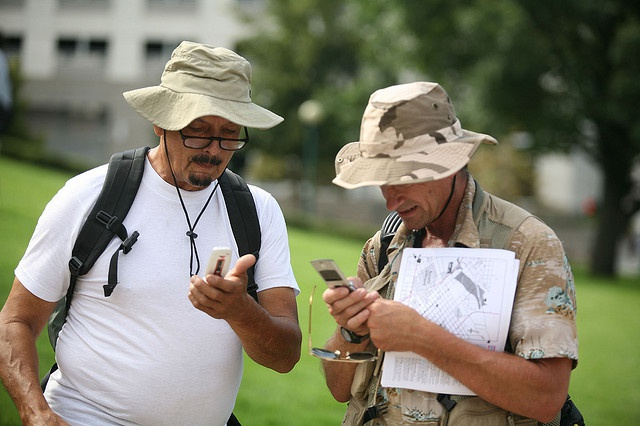Describe the objects in this image and their specific colors. I can see people in gray, lightgray, darkgray, black, and maroon tones, people in gray, darkgray, and maroon tones, backpack in gray, black, darkgray, and lightgray tones, backpack in gray, black, ivory, and darkgray tones, and cell phone in gray, tan, darkgray, and black tones in this image. 